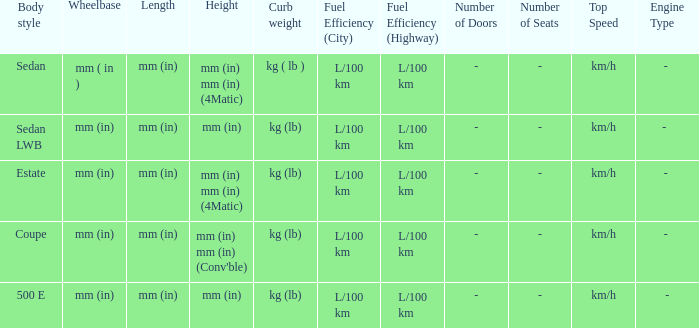What's the length of the model with Sedan body style? Mm (in). 